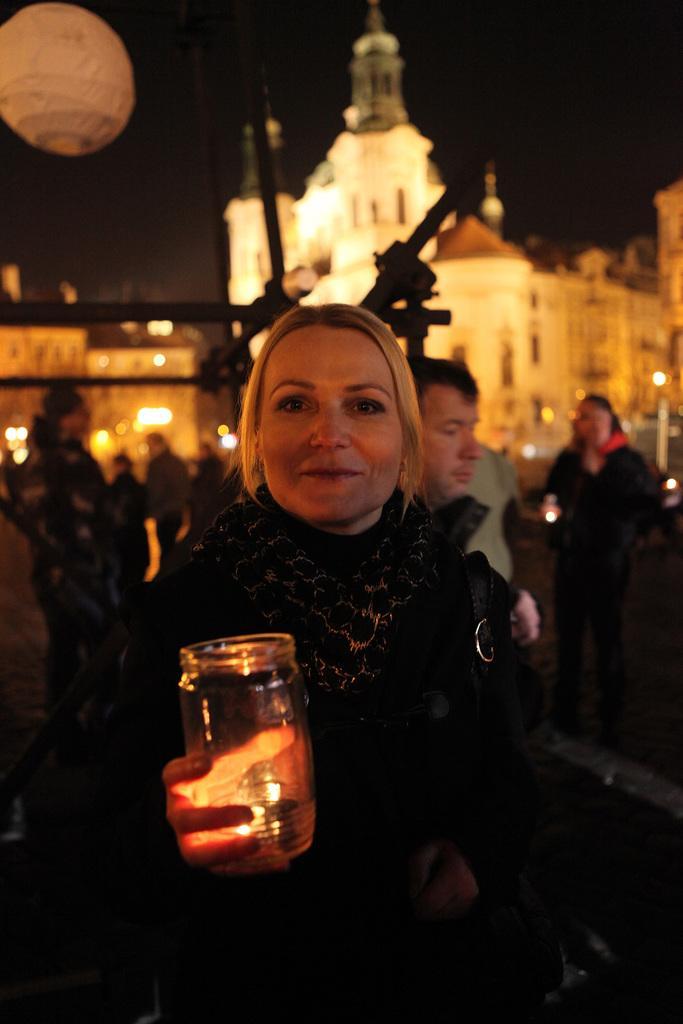Can you describe this image briefly? In the foreground we can see a woman and she is holding a glass bowl in her hand. In the background, we can see the buildings and a few people. 